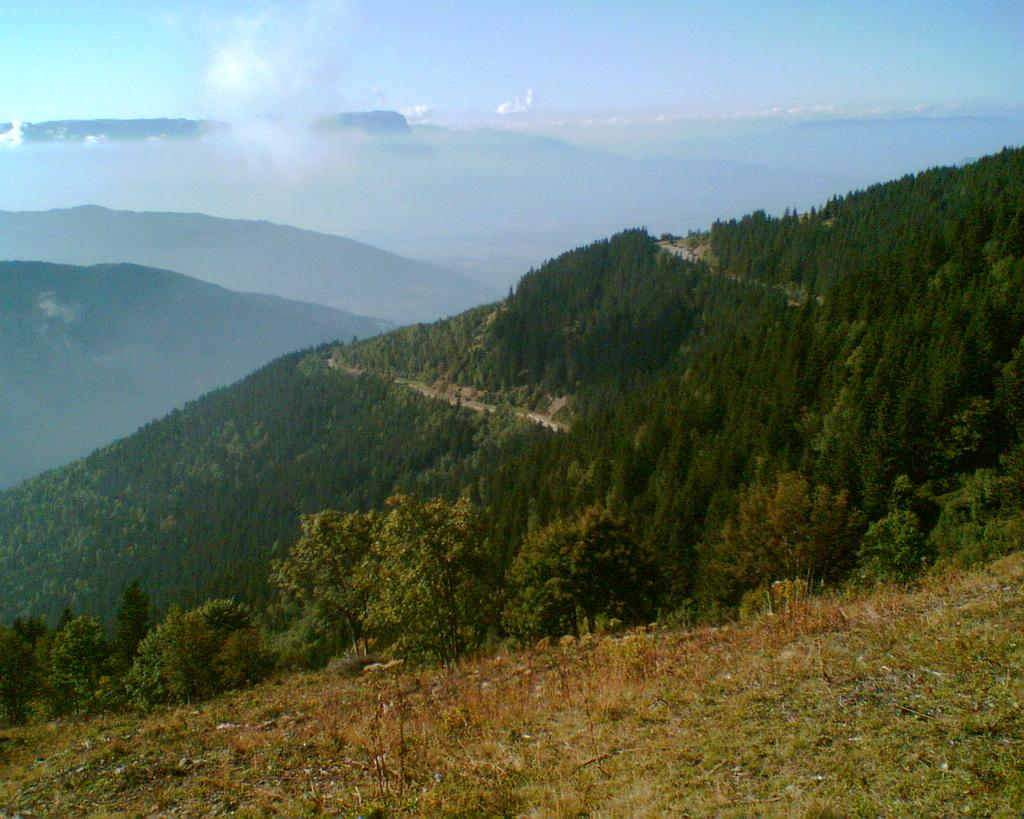What type of vegetation can be seen in the image? There is grass and trees in the image. What type of natural landform is visible in the image? There are mountains in the image. What is visible in the background of the image? The sky is visible in the background of the image. What can be seen in the sky? Clouds are present in the sky. What language is spoken by the doll in the image? There is no doll present in the image, so it is not possible to determine what language might be spoken by a doll. 